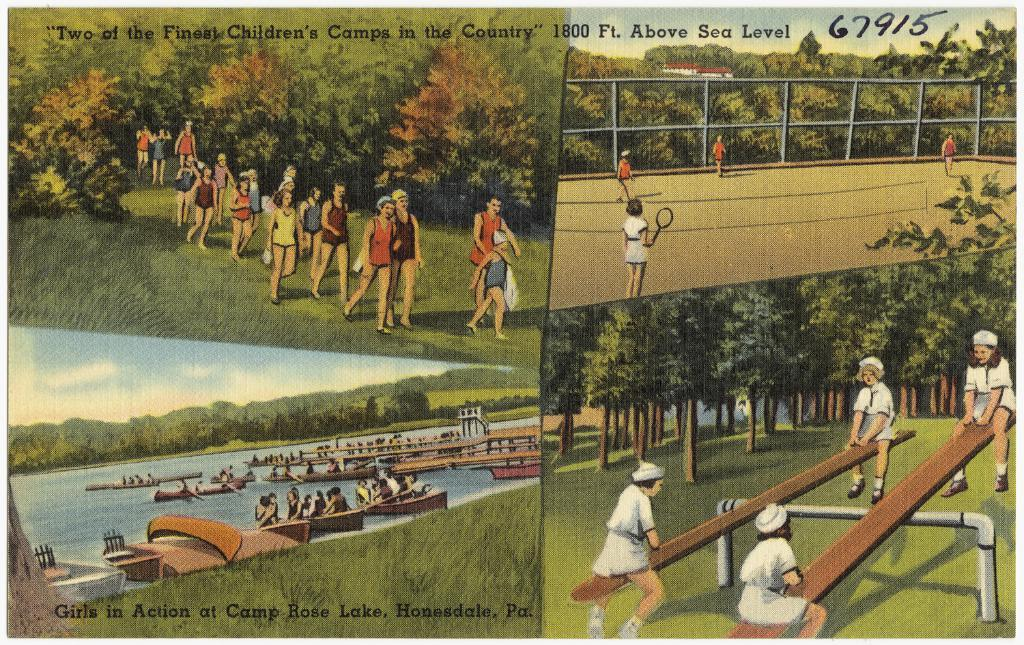<image>
Provide a brief description of the given image. The pictures claim to show two of the finest children's camps in the Country. 